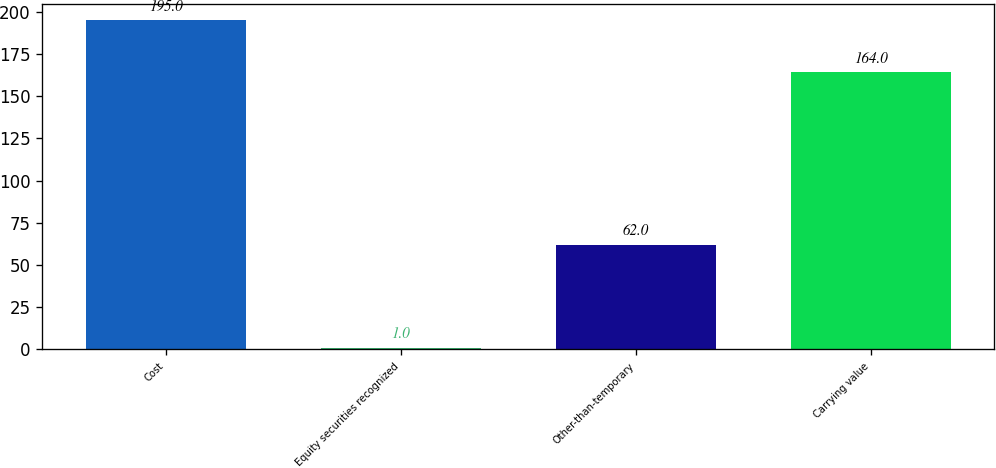Convert chart. <chart><loc_0><loc_0><loc_500><loc_500><bar_chart><fcel>Cost<fcel>Equity securities recognized<fcel>Other-than-temporary<fcel>Carrying value<nl><fcel>195<fcel>1<fcel>62<fcel>164<nl></chart> 